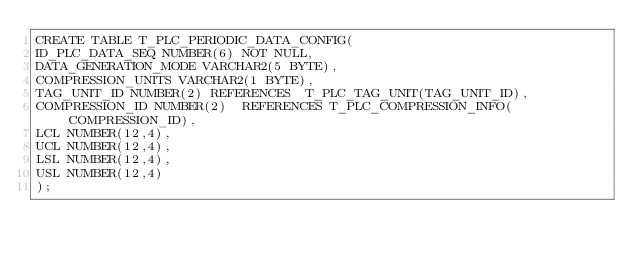<code> <loc_0><loc_0><loc_500><loc_500><_SQL_>CREATE TABLE T_PLC_PERIODIC_DATA_CONFIG(
ID_PLC_DATA_SEQ NUMBER(6) NOT NULL,
DATA_GENERATION_MODE VARCHAR2(5 BYTE),
COMPRESSION_UNITS VARCHAR2(1 BYTE),
TAG_UNIT_ID NUMBER(2) REFERENCES  T_PLC_TAG_UNIT(TAG_UNIT_ID),
COMPRESSION_ID NUMBER(2)  REFERENCES T_PLC_COMPRESSION_INFO(COMPRESSION_ID),
LCL NUMBER(12,4),
UCL NUMBER(12,4),
LSL NUMBER(12,4),
USL NUMBER(12,4)
);</code> 